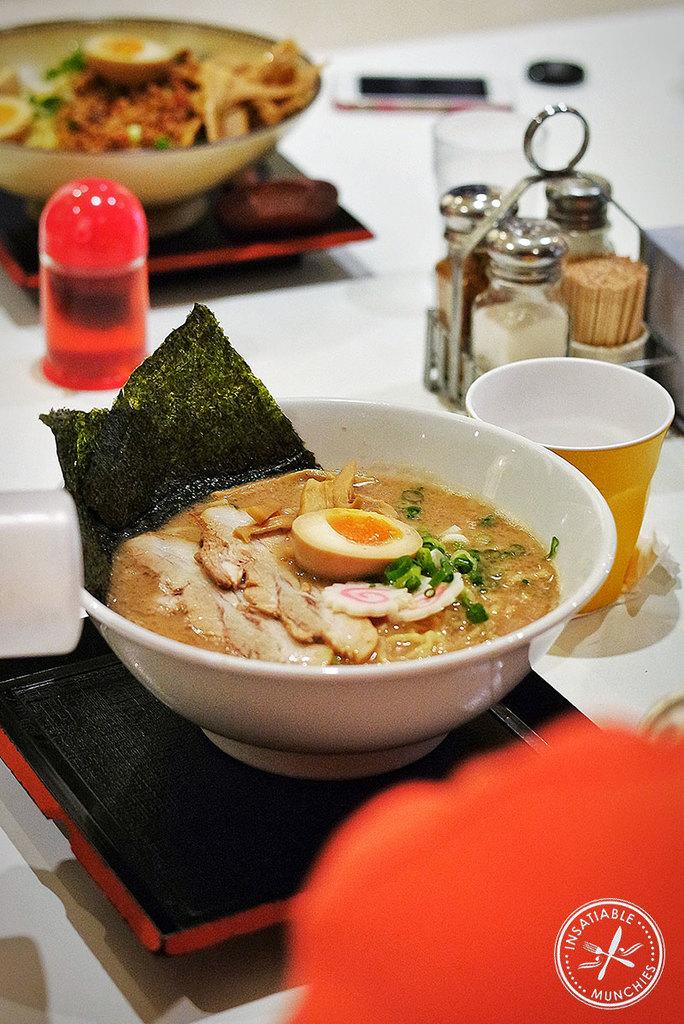What type of containers are present in the image? There are bowls in the image. What is inside the containers? There are food items in the image. What else can be seen in the image besides the containers and food items? There are other objects in the image. Where are all of these items located? All of these items are on a platform. What type of art can be seen in the image? There is no art present in the image; it features bowls, food items, and other objects on a platform. 